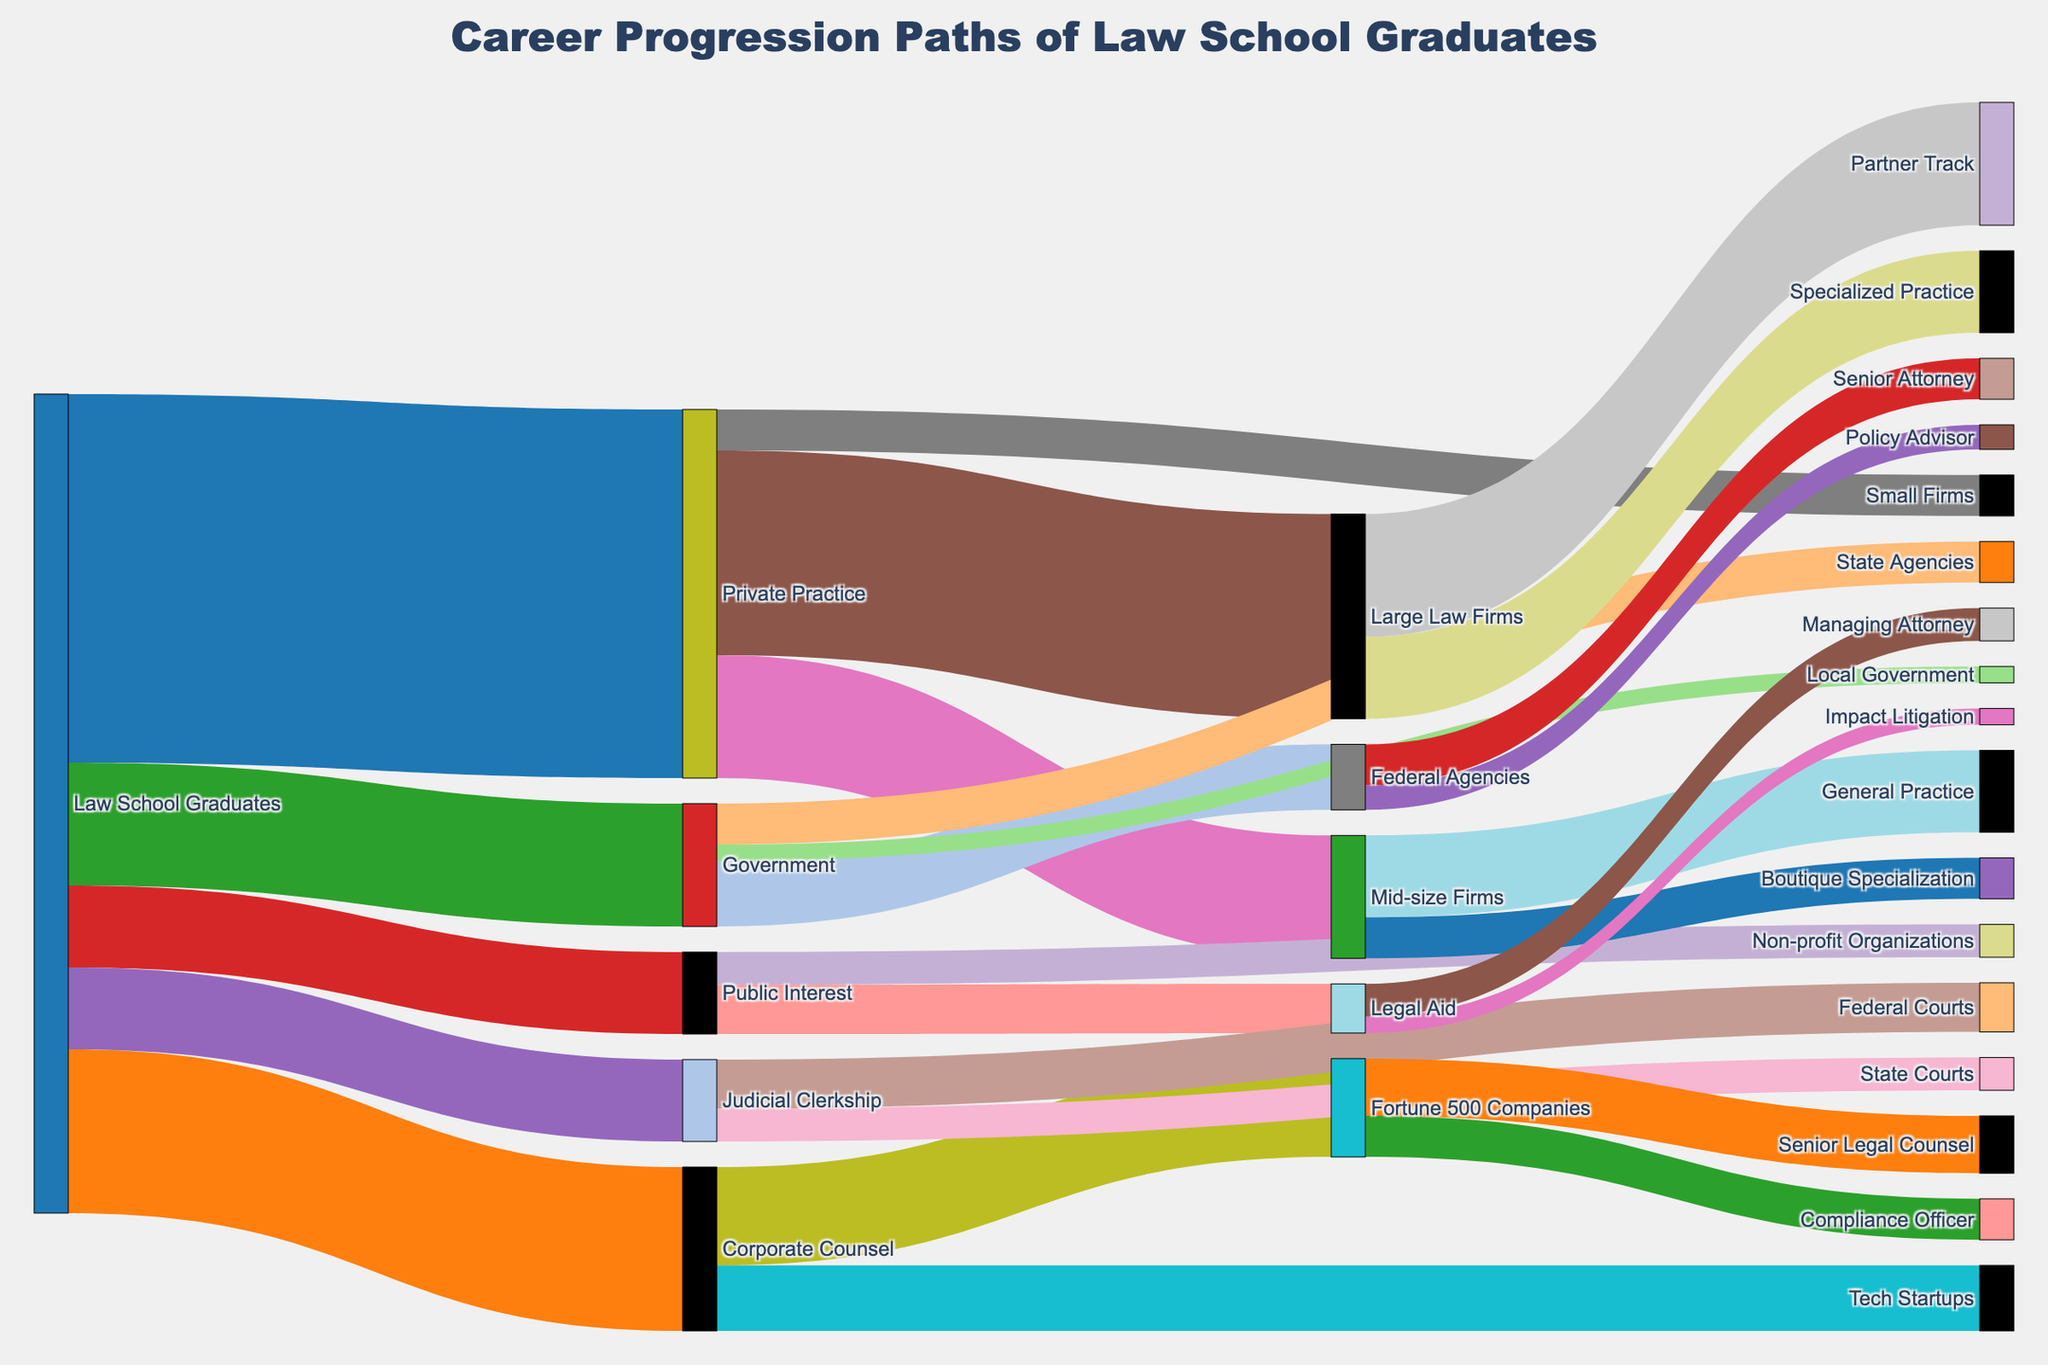Who has the highest number of Law School Graduates? The Sankey diagram shows that Private Practice has the highest number of Law School Graduates. We can see this because the link from "Law School Graduates" to "Private Practice" has the highest value, which is 450.
Answer: Private Practice Which sector has the least Law School Graduates? By examining the thickness of the flows from "Law School Graduates," we can see that Public Interest and Judicial Clerkship both have the lowest value, which is 100 each.
Answer: Public Interest and Judicial Clerkship What is the total number of Law School Graduates working in the Government sector and its branches? We first see the flow from "Law School Graduates" to "Government" which is 150. Then we look at the branches "Federal Agencies" (80), "State Agencies" (50), and "Local Government" (20). The sum of these flows is 150 + 80 + 50 + 20 = 300.
Answer: 300 How many Law School Graduates progressed to "Federal Courts" after "Judicial Clerkship"? We follow the path from "Judicial Clerkship" to "Federal Courts" which has a value of 60.
Answer: 60 Which pathway in Private Practice has the highest number of graduates? From "Private Practice," the flow to "Large Law Firms" is the thickest, with a value of 250. So "Large Law Firms" has the highest number of graduates.
Answer: Large Law Firms Compare the number of graduates in "Large Law Firms" and "Mid-size Firms". Which one is higher and by how much? We see that "Large Law Firms" has 250, and "Mid-size Firms" has 150. The difference is 250 - 150 = 100.
Answer: Large Law Firms, 100 Which career path from "Corporate Counsel" leads to the most specialized roles? From "Corporate Counsel", there are two target roles: "Fortune 500 Companies" (120) and "Tech Startups" (80). Within "Fortune 500 Companies", the options are "Senior Legal Counsel" (70) and "Compliance Officer" (50). The more specialized roles would likely be "Compliance Officer" and "Senior Legal Counsel" within Fortune 500 Companies.
Answer: Fortune 500 Companies What is the total number of Law School Graduates in "Public Interest" roles, including its branches? We take the value from "Law School Graduates" to "Public Interest" (100) and then add the values flowing to its branches: "Legal Aid" (60) and "Non-profit Organizations" (40). The sum is 100 + 60 + 40 = 200.
Answer: 200 How many Law School Graduates end up in a partnership track at "Large Law Firms"? From "Large Law Firms," the flow to "Partner Track" is labeled as 150.
Answer: 150 